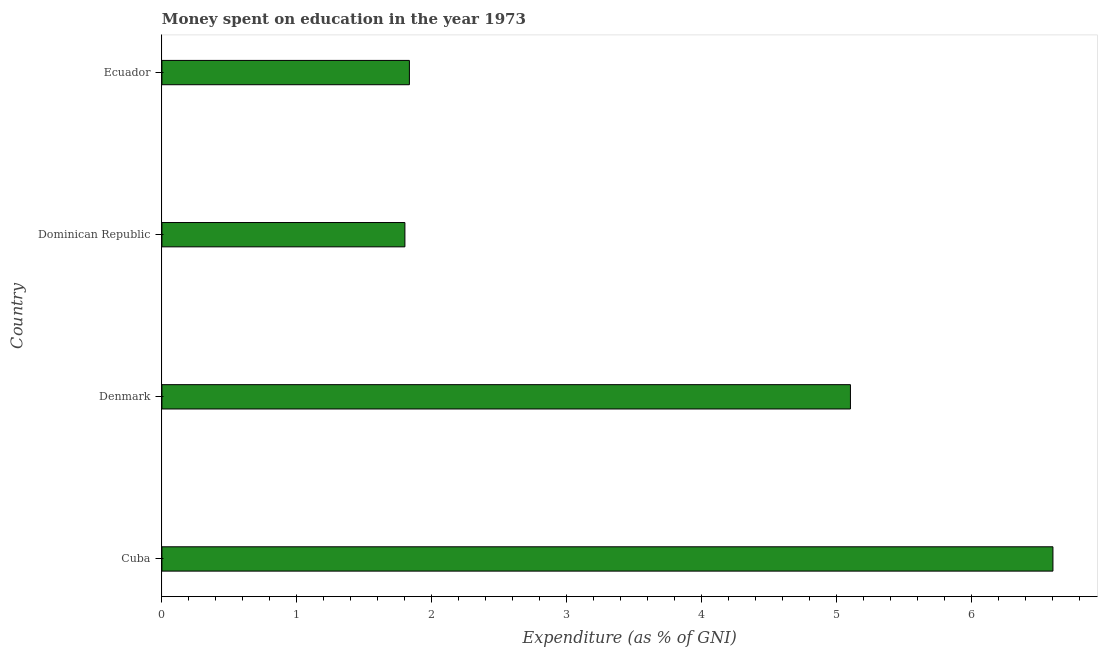Does the graph contain any zero values?
Provide a short and direct response. No. What is the title of the graph?
Your answer should be very brief. Money spent on education in the year 1973. What is the label or title of the X-axis?
Your answer should be compact. Expenditure (as % of GNI). What is the label or title of the Y-axis?
Offer a very short reply. Country. Across all countries, what is the maximum expenditure on education?
Offer a terse response. 6.6. Across all countries, what is the minimum expenditure on education?
Give a very brief answer. 1.8. In which country was the expenditure on education maximum?
Give a very brief answer. Cuba. In which country was the expenditure on education minimum?
Your answer should be compact. Dominican Republic. What is the sum of the expenditure on education?
Keep it short and to the point. 15.33. What is the average expenditure on education per country?
Keep it short and to the point. 3.83. What is the median expenditure on education?
Your answer should be compact. 3.47. Is the expenditure on education in Cuba less than that in Dominican Republic?
Provide a succinct answer. No. Is the difference between the expenditure on education in Cuba and Ecuador greater than the difference between any two countries?
Your response must be concise. No. Is the sum of the expenditure on education in Cuba and Dominican Republic greater than the maximum expenditure on education across all countries?
Provide a short and direct response. Yes. Are all the bars in the graph horizontal?
Offer a very short reply. Yes. What is the difference between two consecutive major ticks on the X-axis?
Your answer should be very brief. 1. What is the Expenditure (as % of GNI) of Cuba?
Provide a short and direct response. 6.6. What is the Expenditure (as % of GNI) of Denmark?
Keep it short and to the point. 5.1. What is the Expenditure (as % of GNI) in Dominican Republic?
Your response must be concise. 1.8. What is the Expenditure (as % of GNI) of Ecuador?
Offer a terse response. 1.83. What is the difference between the Expenditure (as % of GNI) in Cuba and Denmark?
Offer a terse response. 1.5. What is the difference between the Expenditure (as % of GNI) in Cuba and Dominican Republic?
Give a very brief answer. 4.8. What is the difference between the Expenditure (as % of GNI) in Cuba and Ecuador?
Make the answer very short. 4.77. What is the difference between the Expenditure (as % of GNI) in Denmark and Ecuador?
Your response must be concise. 3.27. What is the difference between the Expenditure (as % of GNI) in Dominican Republic and Ecuador?
Provide a short and direct response. -0.03. What is the ratio of the Expenditure (as % of GNI) in Cuba to that in Denmark?
Provide a succinct answer. 1.29. What is the ratio of the Expenditure (as % of GNI) in Cuba to that in Dominican Republic?
Provide a succinct answer. 3.67. What is the ratio of the Expenditure (as % of GNI) in Cuba to that in Ecuador?
Ensure brevity in your answer.  3.6. What is the ratio of the Expenditure (as % of GNI) in Denmark to that in Dominican Republic?
Your answer should be compact. 2.83. What is the ratio of the Expenditure (as % of GNI) in Denmark to that in Ecuador?
Provide a succinct answer. 2.78. 